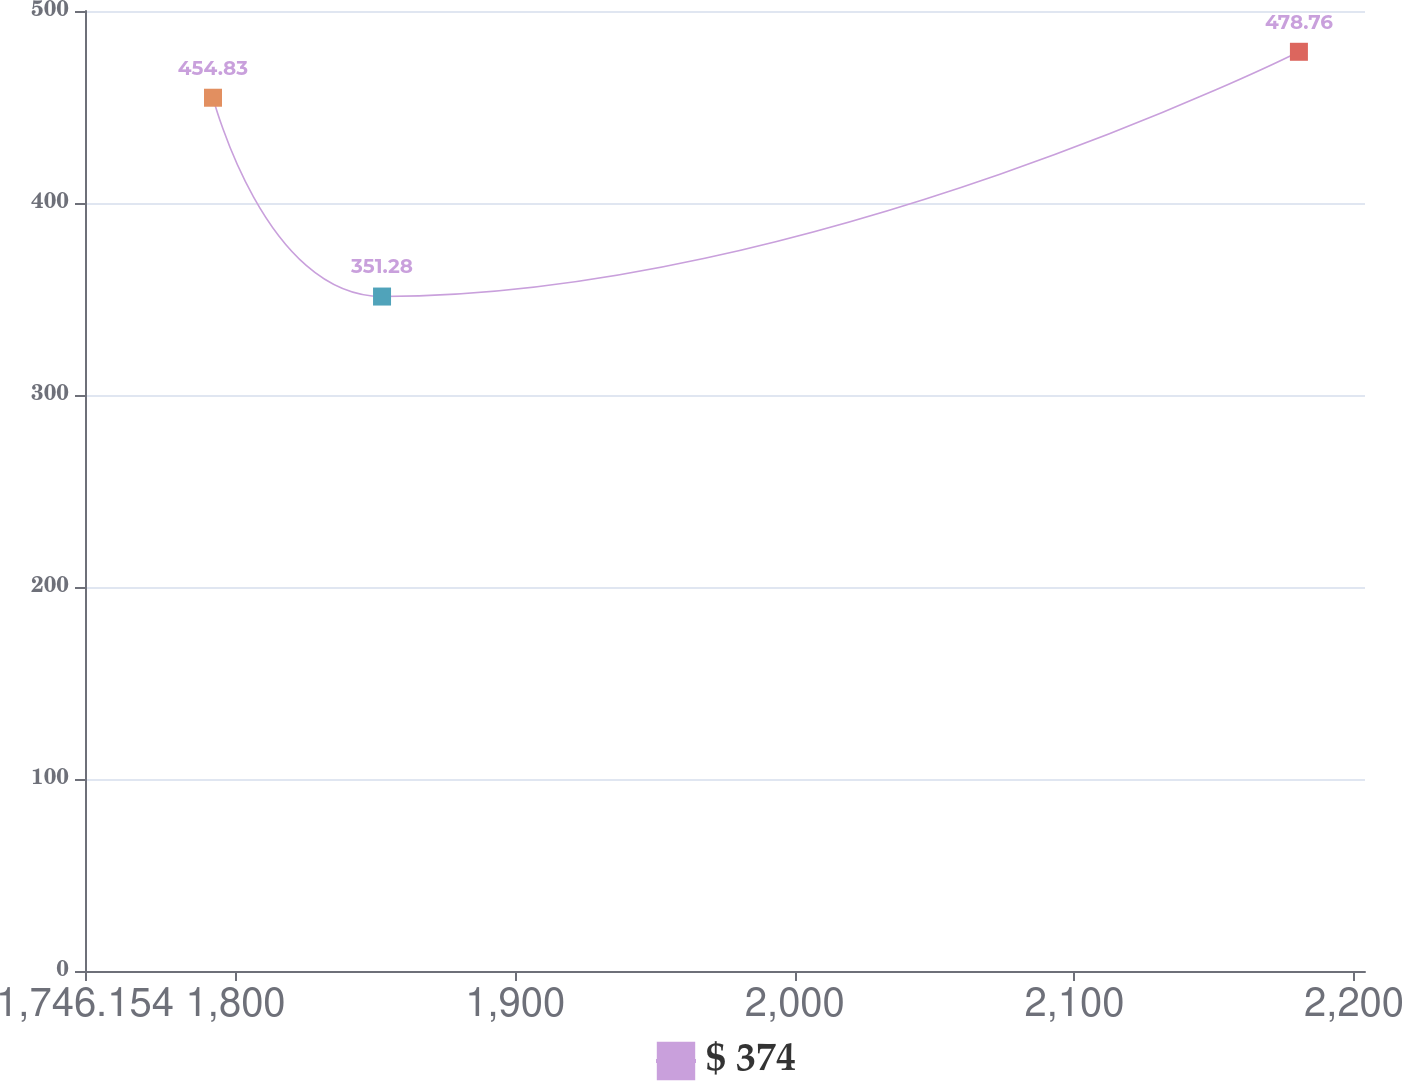<chart> <loc_0><loc_0><loc_500><loc_500><line_chart><ecel><fcel>$ 374<nl><fcel>1791.93<fcel>454.83<nl><fcel>1852.38<fcel>351.28<nl><fcel>2180.28<fcel>478.76<nl><fcel>2249.69<fcel>492.71<nl></chart> 